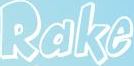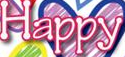Read the text from these images in sequence, separated by a semicolon. Rake; Happy 